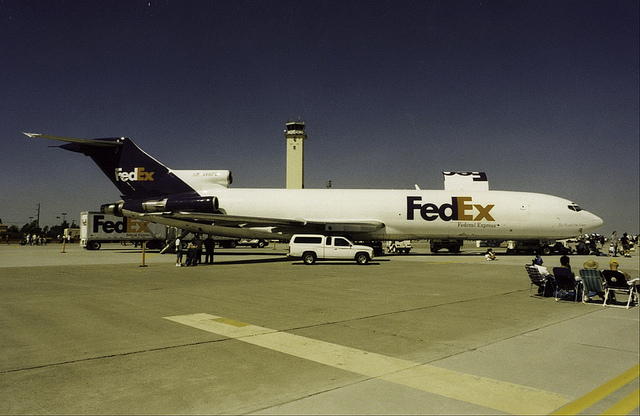Extract all visible text content from this image. FedEX FedEx FedEX 